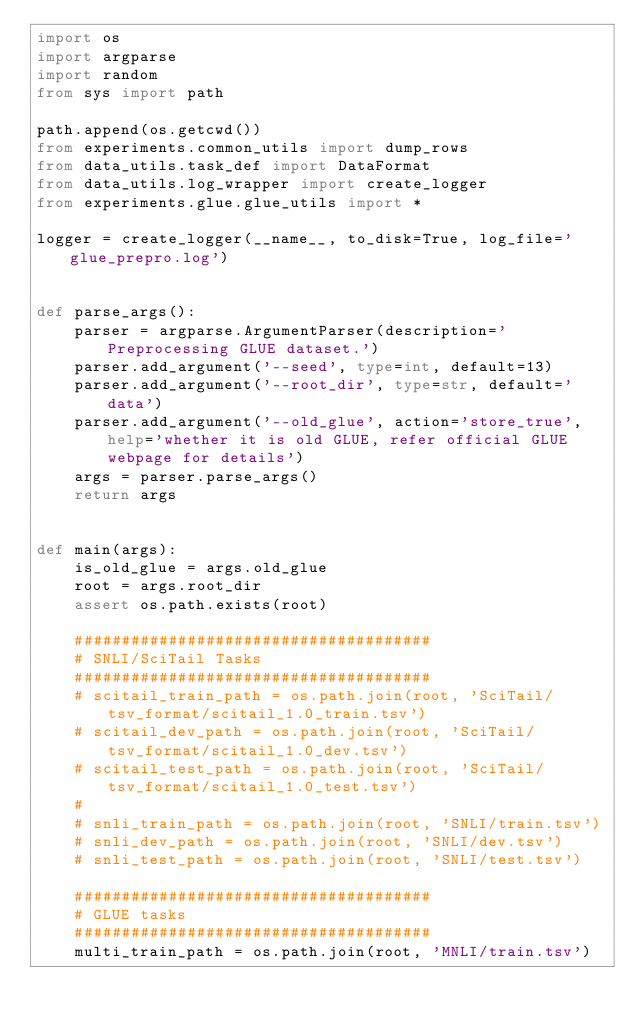Convert code to text. <code><loc_0><loc_0><loc_500><loc_500><_Python_>import os
import argparse
import random
from sys import path

path.append(os.getcwd())
from experiments.common_utils import dump_rows
from data_utils.task_def import DataFormat
from data_utils.log_wrapper import create_logger
from experiments.glue.glue_utils import *

logger = create_logger(__name__, to_disk=True, log_file='glue_prepro.log')


def parse_args():
    parser = argparse.ArgumentParser(description='Preprocessing GLUE dataset.')
    parser.add_argument('--seed', type=int, default=13)
    parser.add_argument('--root_dir', type=str, default='data')
    parser.add_argument('--old_glue', action='store_true', help='whether it is old GLUE, refer official GLUE webpage for details')
    args = parser.parse_args()
    return args


def main(args):
    is_old_glue = args.old_glue
    root = args.root_dir
    assert os.path.exists(root)

    ######################################
    # SNLI/SciTail Tasks
    ######################################
    # scitail_train_path = os.path.join(root, 'SciTail/tsv_format/scitail_1.0_train.tsv')
    # scitail_dev_path = os.path.join(root, 'SciTail/tsv_format/scitail_1.0_dev.tsv')
    # scitail_test_path = os.path.join(root, 'SciTail/tsv_format/scitail_1.0_test.tsv')
    #
    # snli_train_path = os.path.join(root, 'SNLI/train.tsv')
    # snli_dev_path = os.path.join(root, 'SNLI/dev.tsv')
    # snli_test_path = os.path.join(root, 'SNLI/test.tsv')

    ######################################
    # GLUE tasks
    ######################################
    multi_train_path = os.path.join(root, 'MNLI/train.tsv')</code> 